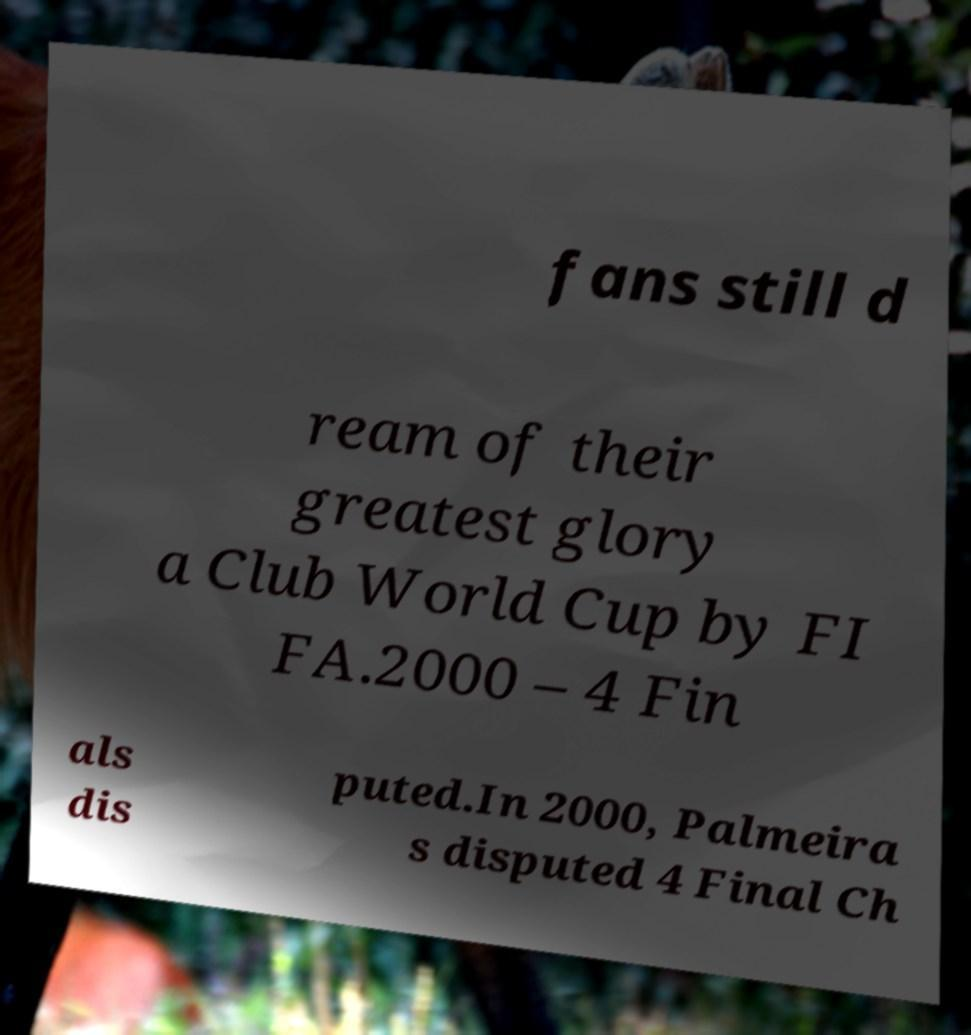Please identify and transcribe the text found in this image. fans still d ream of their greatest glory a Club World Cup by FI FA.2000 – 4 Fin als dis puted.In 2000, Palmeira s disputed 4 Final Ch 